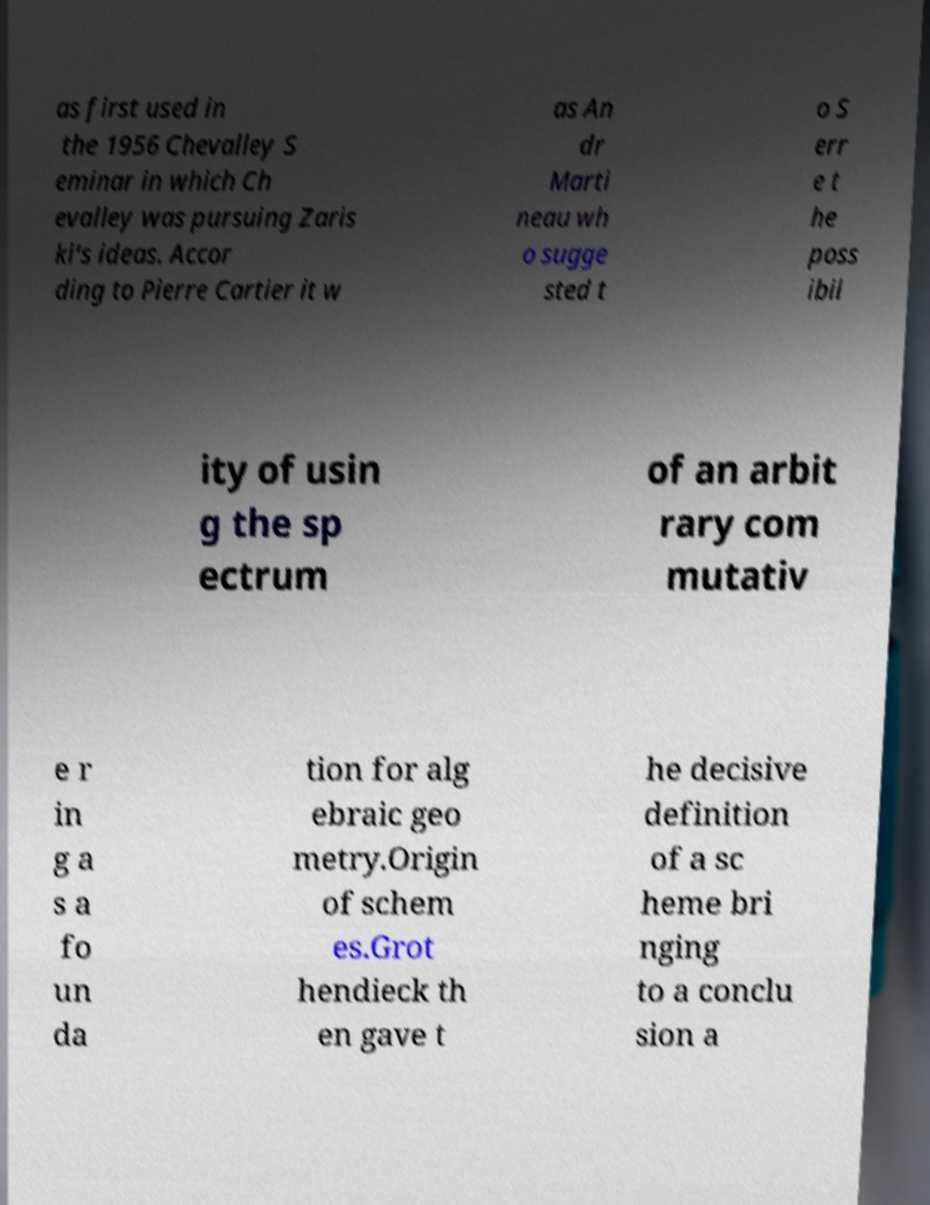I need the written content from this picture converted into text. Can you do that? as first used in the 1956 Chevalley S eminar in which Ch evalley was pursuing Zaris ki's ideas. Accor ding to Pierre Cartier it w as An dr Marti neau wh o sugge sted t o S err e t he poss ibil ity of usin g the sp ectrum of an arbit rary com mutativ e r in g a s a fo un da tion for alg ebraic geo metry.Origin of schem es.Grot hendieck th en gave t he decisive definition of a sc heme bri nging to a conclu sion a 